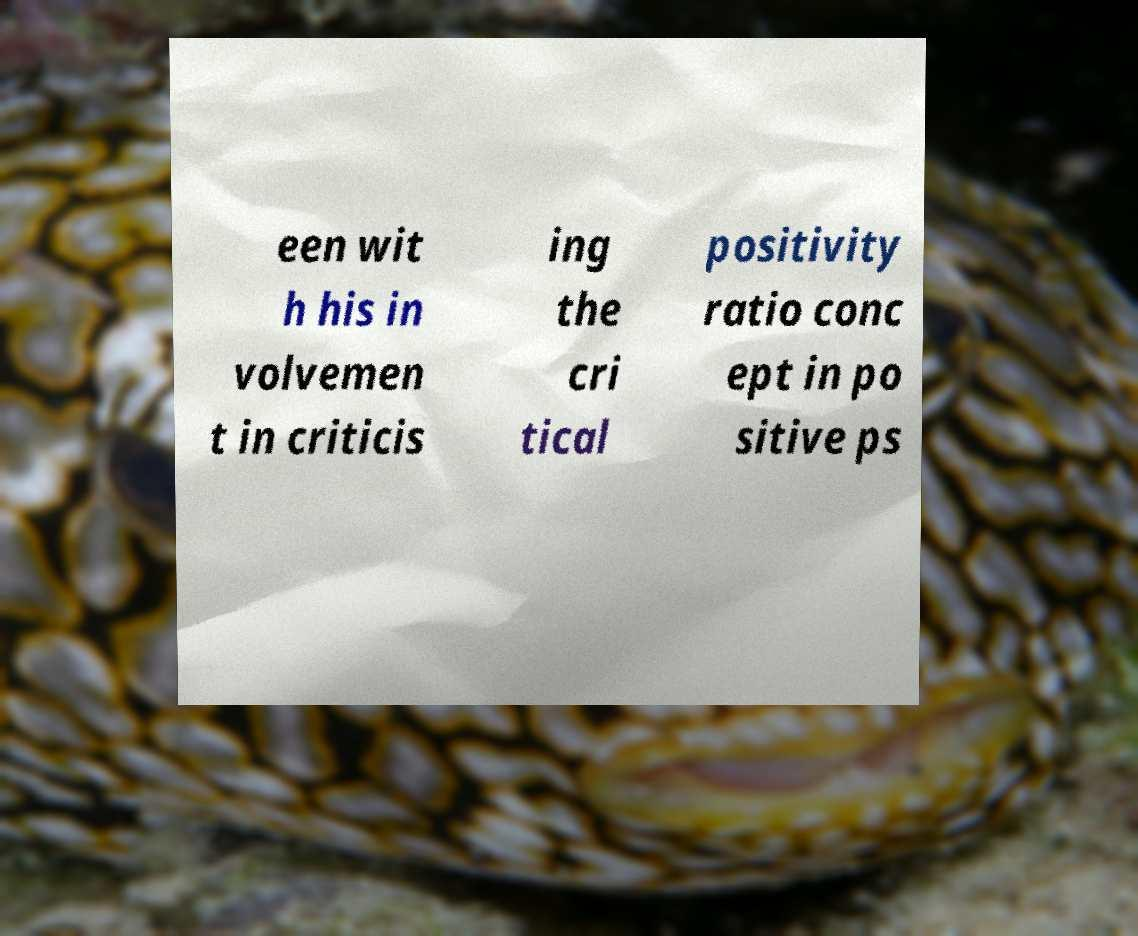I need the written content from this picture converted into text. Can you do that? een wit h his in volvemen t in criticis ing the cri tical positivity ratio conc ept in po sitive ps 